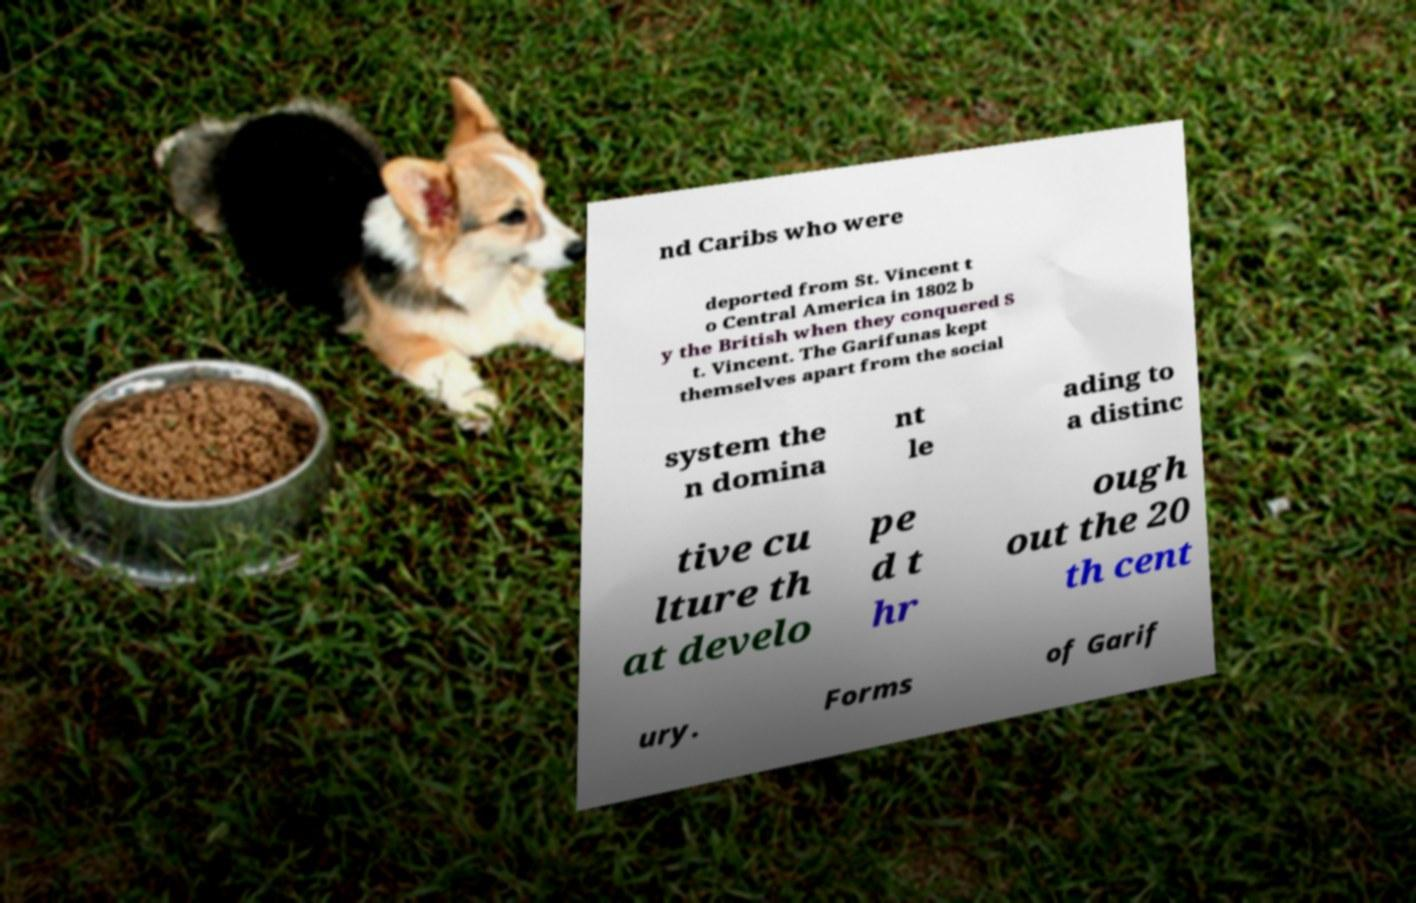Could you assist in decoding the text presented in this image and type it out clearly? nd Caribs who were deported from St. Vincent t o Central America in 1802 b y the British when they conquered S t. Vincent. The Garifunas kept themselves apart from the social system the n domina nt le ading to a distinc tive cu lture th at develo pe d t hr ough out the 20 th cent ury. Forms of Garif 